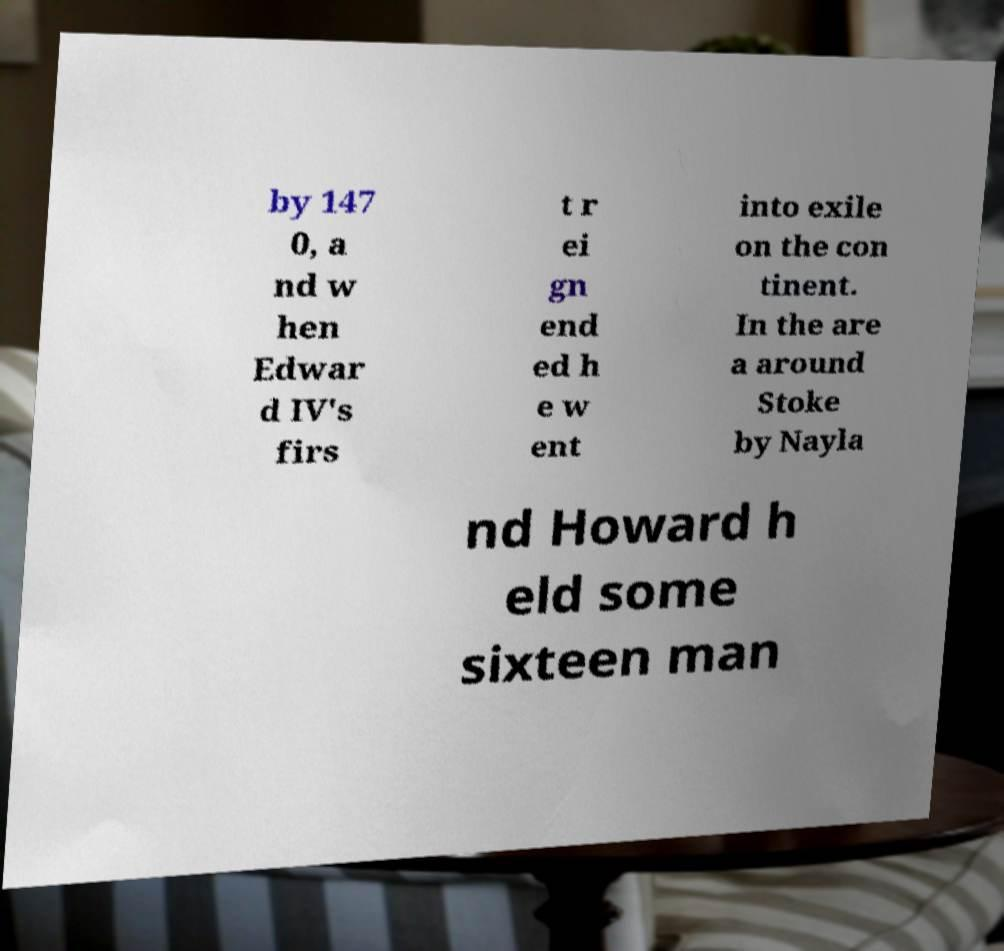Can you accurately transcribe the text from the provided image for me? by 147 0, a nd w hen Edwar d IV's firs t r ei gn end ed h e w ent into exile on the con tinent. In the are a around Stoke by Nayla nd Howard h eld some sixteen man 